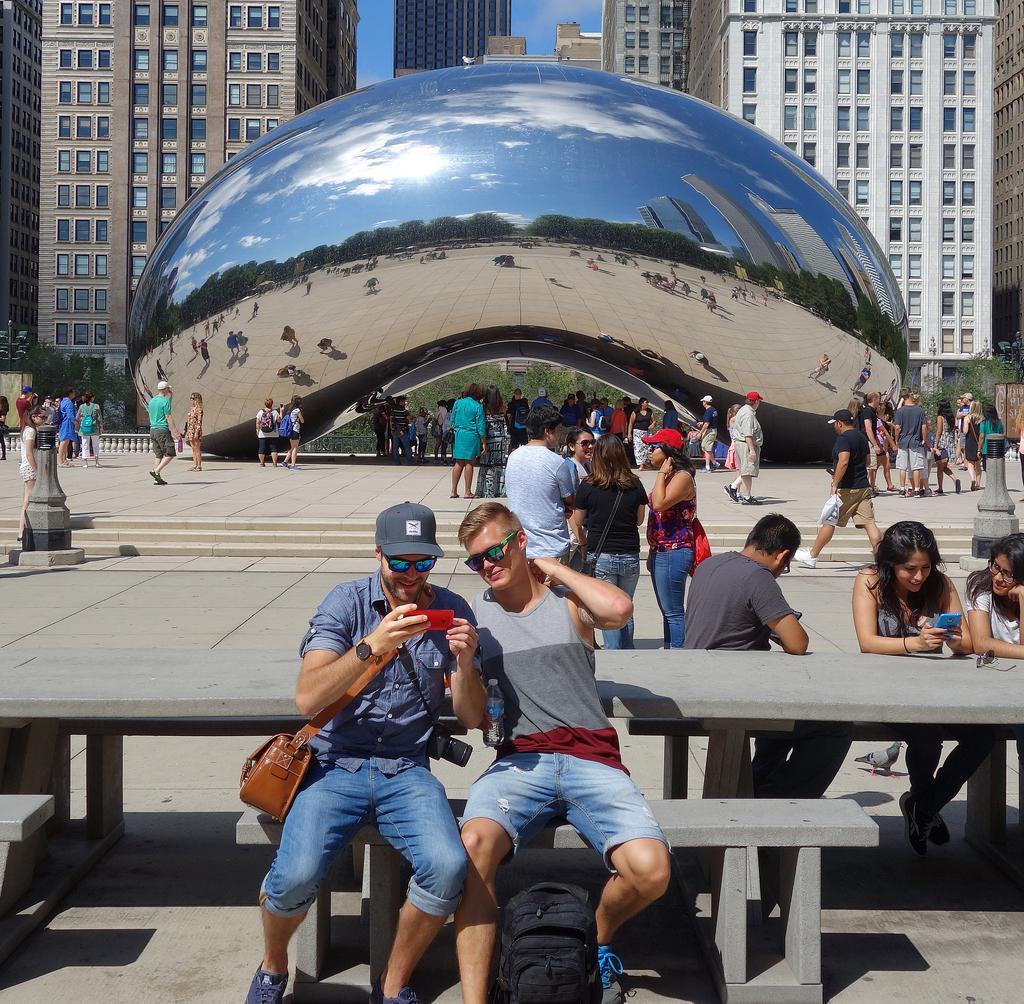Can you describe this image briefly? In this picture we can see an object, buildings with windows, trees, poles, tables and a group of people, some are sitting on benches, some are standing and some are walking on the ground, goggles, caps, bags and in the background we can see the sky. 